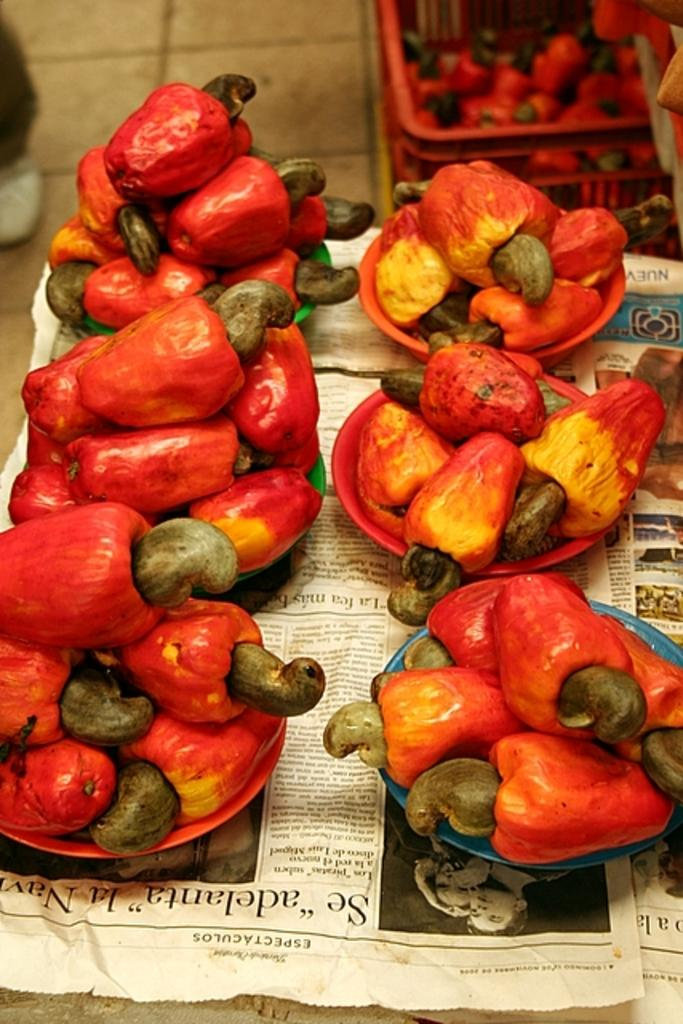What type of food is present on the plates in the image? There are red bell peppers on plates in the image. Where are the plates with red bell peppers located? The plates are on a table. Can you describe the background of the image? In the background of the image, there are red bell peppers in a bin. What type of friction can be observed between the red bell peppers and the plates in the image? There is no mention of friction in the image, as it focuses on the presence and location of red bell peppers on plates and in a bin. 